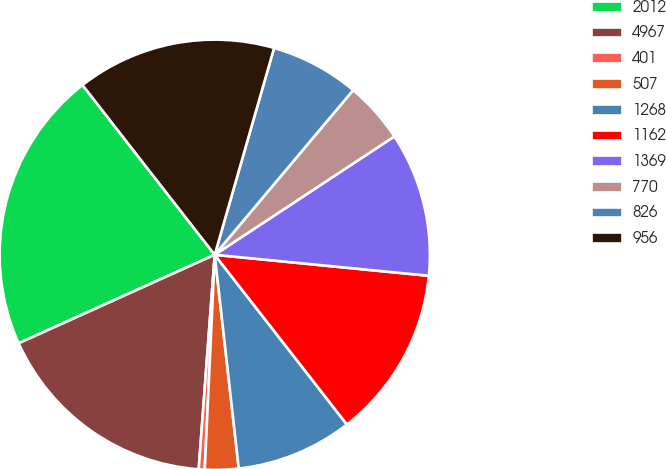<chart> <loc_0><loc_0><loc_500><loc_500><pie_chart><fcel>2012<fcel>4967<fcel>401<fcel>507<fcel>1268<fcel>1162<fcel>1369<fcel>770<fcel>826<fcel>956<nl><fcel>21.22%<fcel>17.06%<fcel>0.45%<fcel>2.52%<fcel>8.75%<fcel>12.91%<fcel>10.83%<fcel>4.6%<fcel>6.68%<fcel>14.98%<nl></chart> 